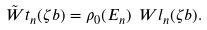<formula> <loc_0><loc_0><loc_500><loc_500>\tilde { \ W t } _ { n } ( \zeta b ) = \rho _ { 0 } ( E _ { n } ) \ W l _ { n } ( \zeta b ) .</formula> 